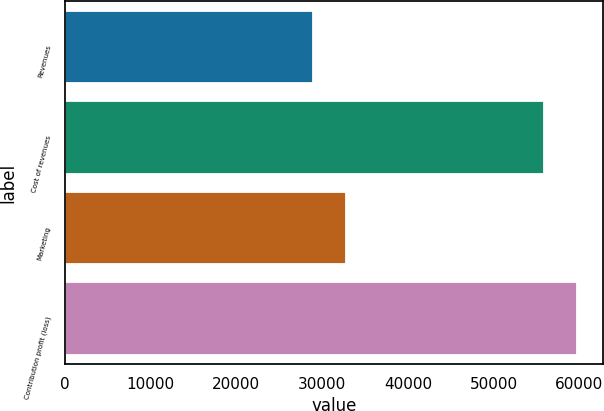Convert chart to OTSL. <chart><loc_0><loc_0><loc_500><loc_500><bar_chart><fcel>Revenues<fcel>Cost of revenues<fcel>Marketing<fcel>Contribution profit (loss)<nl><fcel>28988<fcel>55909<fcel>32822<fcel>59743<nl></chart> 